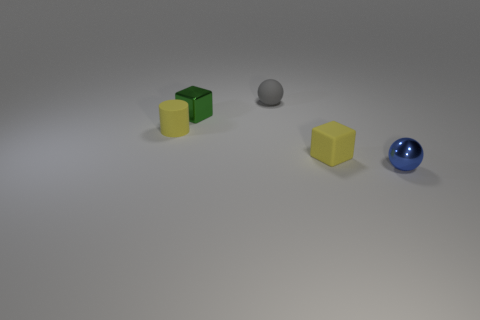Is the shape of the rubber thing to the right of the small gray rubber sphere the same as  the green metallic object?
Offer a terse response. Yes. Is the number of tiny things in front of the gray object greater than the number of tiny green things right of the blue ball?
Give a very brief answer. Yes. How many other objects are there of the same size as the green metal cube?
Ensure brevity in your answer.  4. Is the shape of the blue object the same as the thing that is behind the tiny shiny cube?
Provide a succinct answer. Yes. How many matte things are yellow cylinders or small yellow blocks?
Your response must be concise. 2. Is there a large thing that has the same color as the rubber cylinder?
Keep it short and to the point. No. Are any yellow cylinders visible?
Offer a terse response. Yes. Is the tiny blue metallic thing the same shape as the small gray matte thing?
Give a very brief answer. Yes. How many large objects are either gray balls or red shiny things?
Offer a terse response. 0. The small metallic sphere has what color?
Give a very brief answer. Blue. 